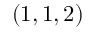Convert formula to latex. <formula><loc_0><loc_0><loc_500><loc_500>( 1 , 1 , 2 )</formula> 